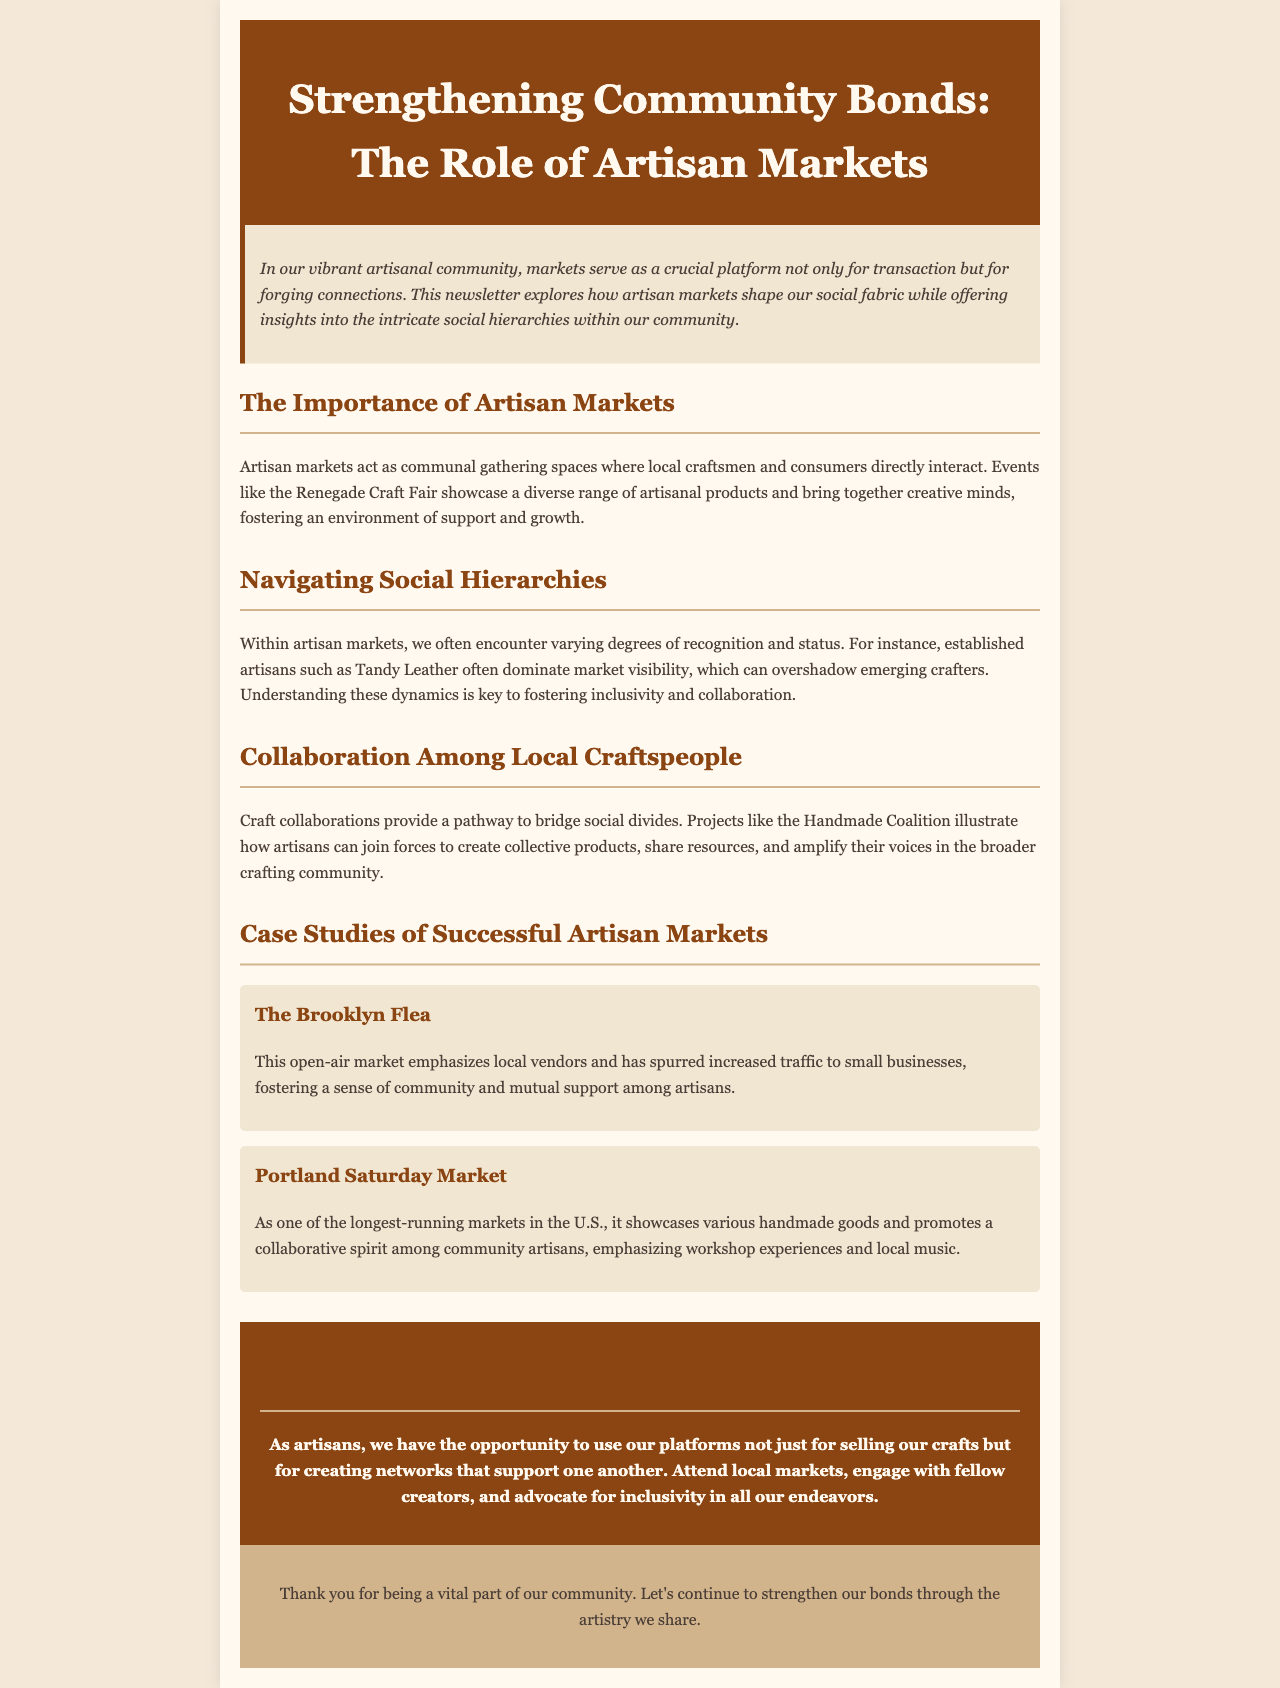What is the title of the newsletter? The title is clearly stated at the top of the document, emphasizing the focus on artisan markets and community bonding.
Answer: Strengthening Community Bonds: The Role of Artisan Markets What is the background color of the body? The document specifies a background color for the body, which is mentioned in the styling section.
Answer: #f4e8d9 Who are the established artisans mentioned in the document? The document makes a reference to specific established artisans that dominate market visibility, which is a key point in understanding social dynamics.
Answer: Tandy Leather What is one of the case studies highlighted? The document lists specific case studies that illustrate successful artisan markets, demonstrating their impact on community.
Answer: The Brooklyn Flea What does the Handmade Coalition represent? The document describes this project as a collaboration among artisans, which highlights community building among local craftspeople.
Answer: Craft collaborations What kind of market is the Portland Saturday Market known as? The document identifies the market's status to show its longevity and importance in promoting artisan work.
Answer: One of the longest-running markets in the U.S What does the call to action encourage artisans to do? The conclusion section emphasizes the importance of engaging with community creators and promoting inclusivity among artisans.
Answer: Attend local markets How does the Brooklyn Flea market affect small businesses? The document mentions a specific positive outcome that enhances the community and supports local artisans through this market.
Answer: Increased traffic to small businesses What style is the newsletter designed to reflect? The document describes the overall style of the newsletter, which includes elements of the artistry shared within the community.
Answer: Artisanal and supportive 